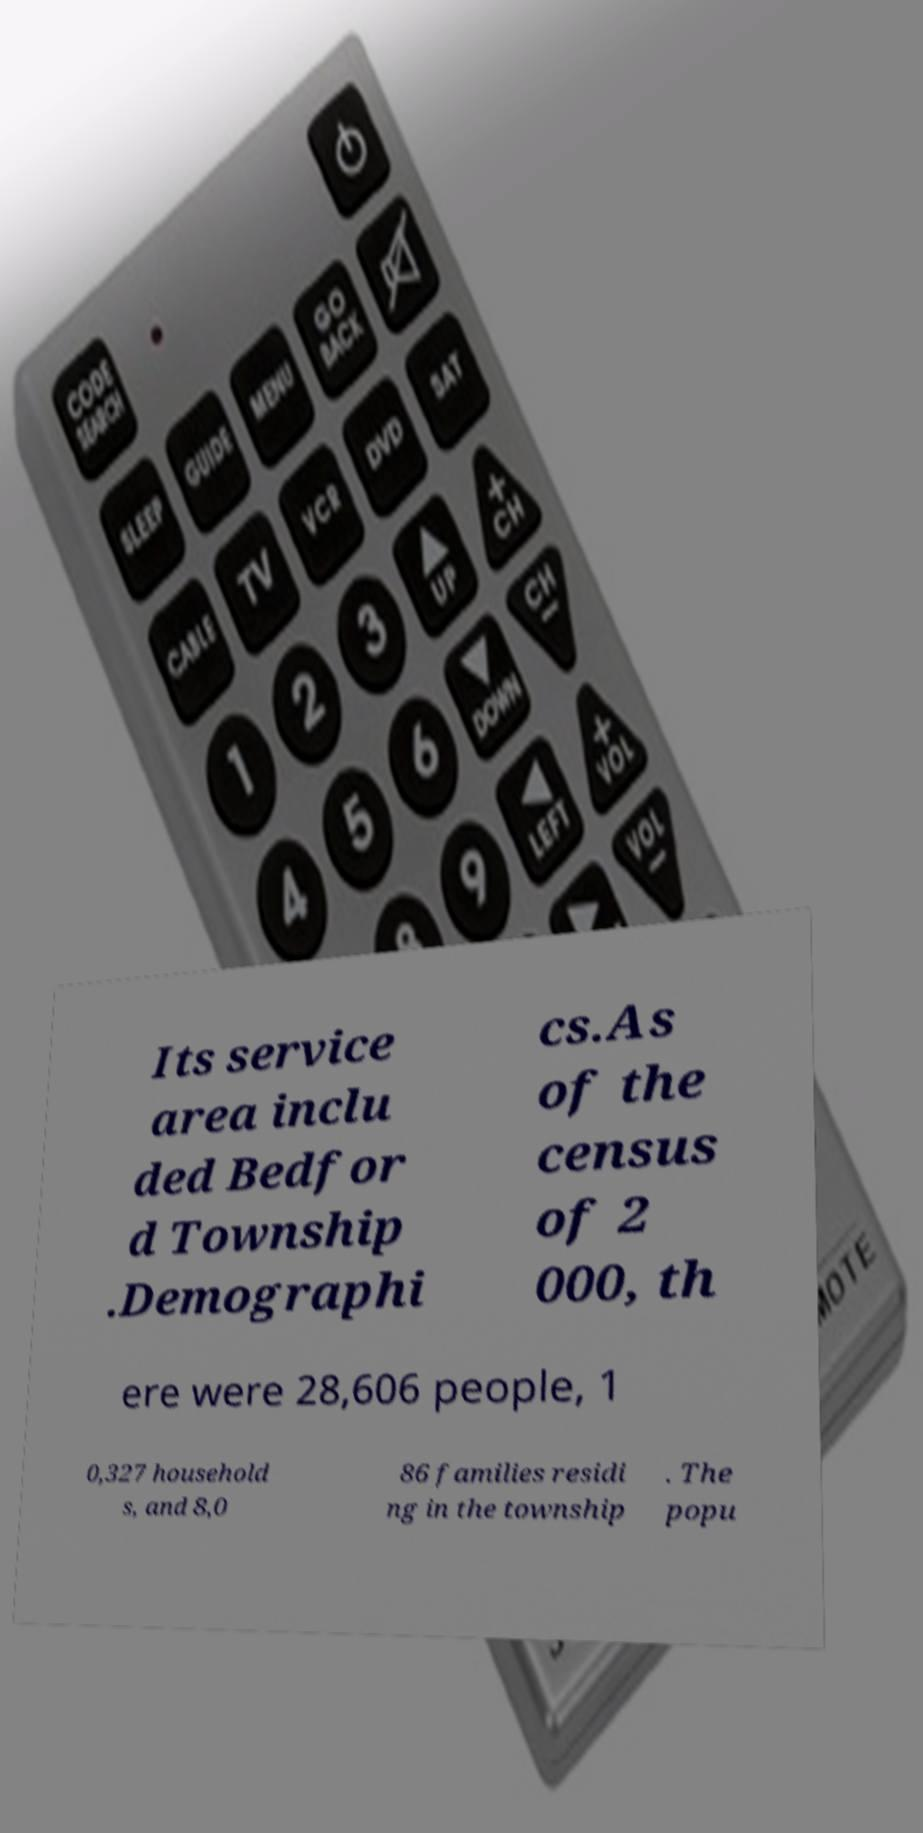Could you extract and type out the text from this image? Its service area inclu ded Bedfor d Township .Demographi cs.As of the census of 2 000, th ere were 28,606 people, 1 0,327 household s, and 8,0 86 families residi ng in the township . The popu 